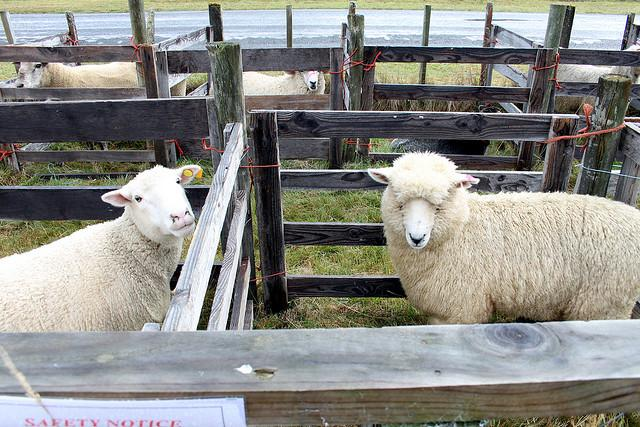What color is the twine that is tied between the cages carrying sheep? Please explain your reasoning. red. The color in option a matches the color of the twine. 